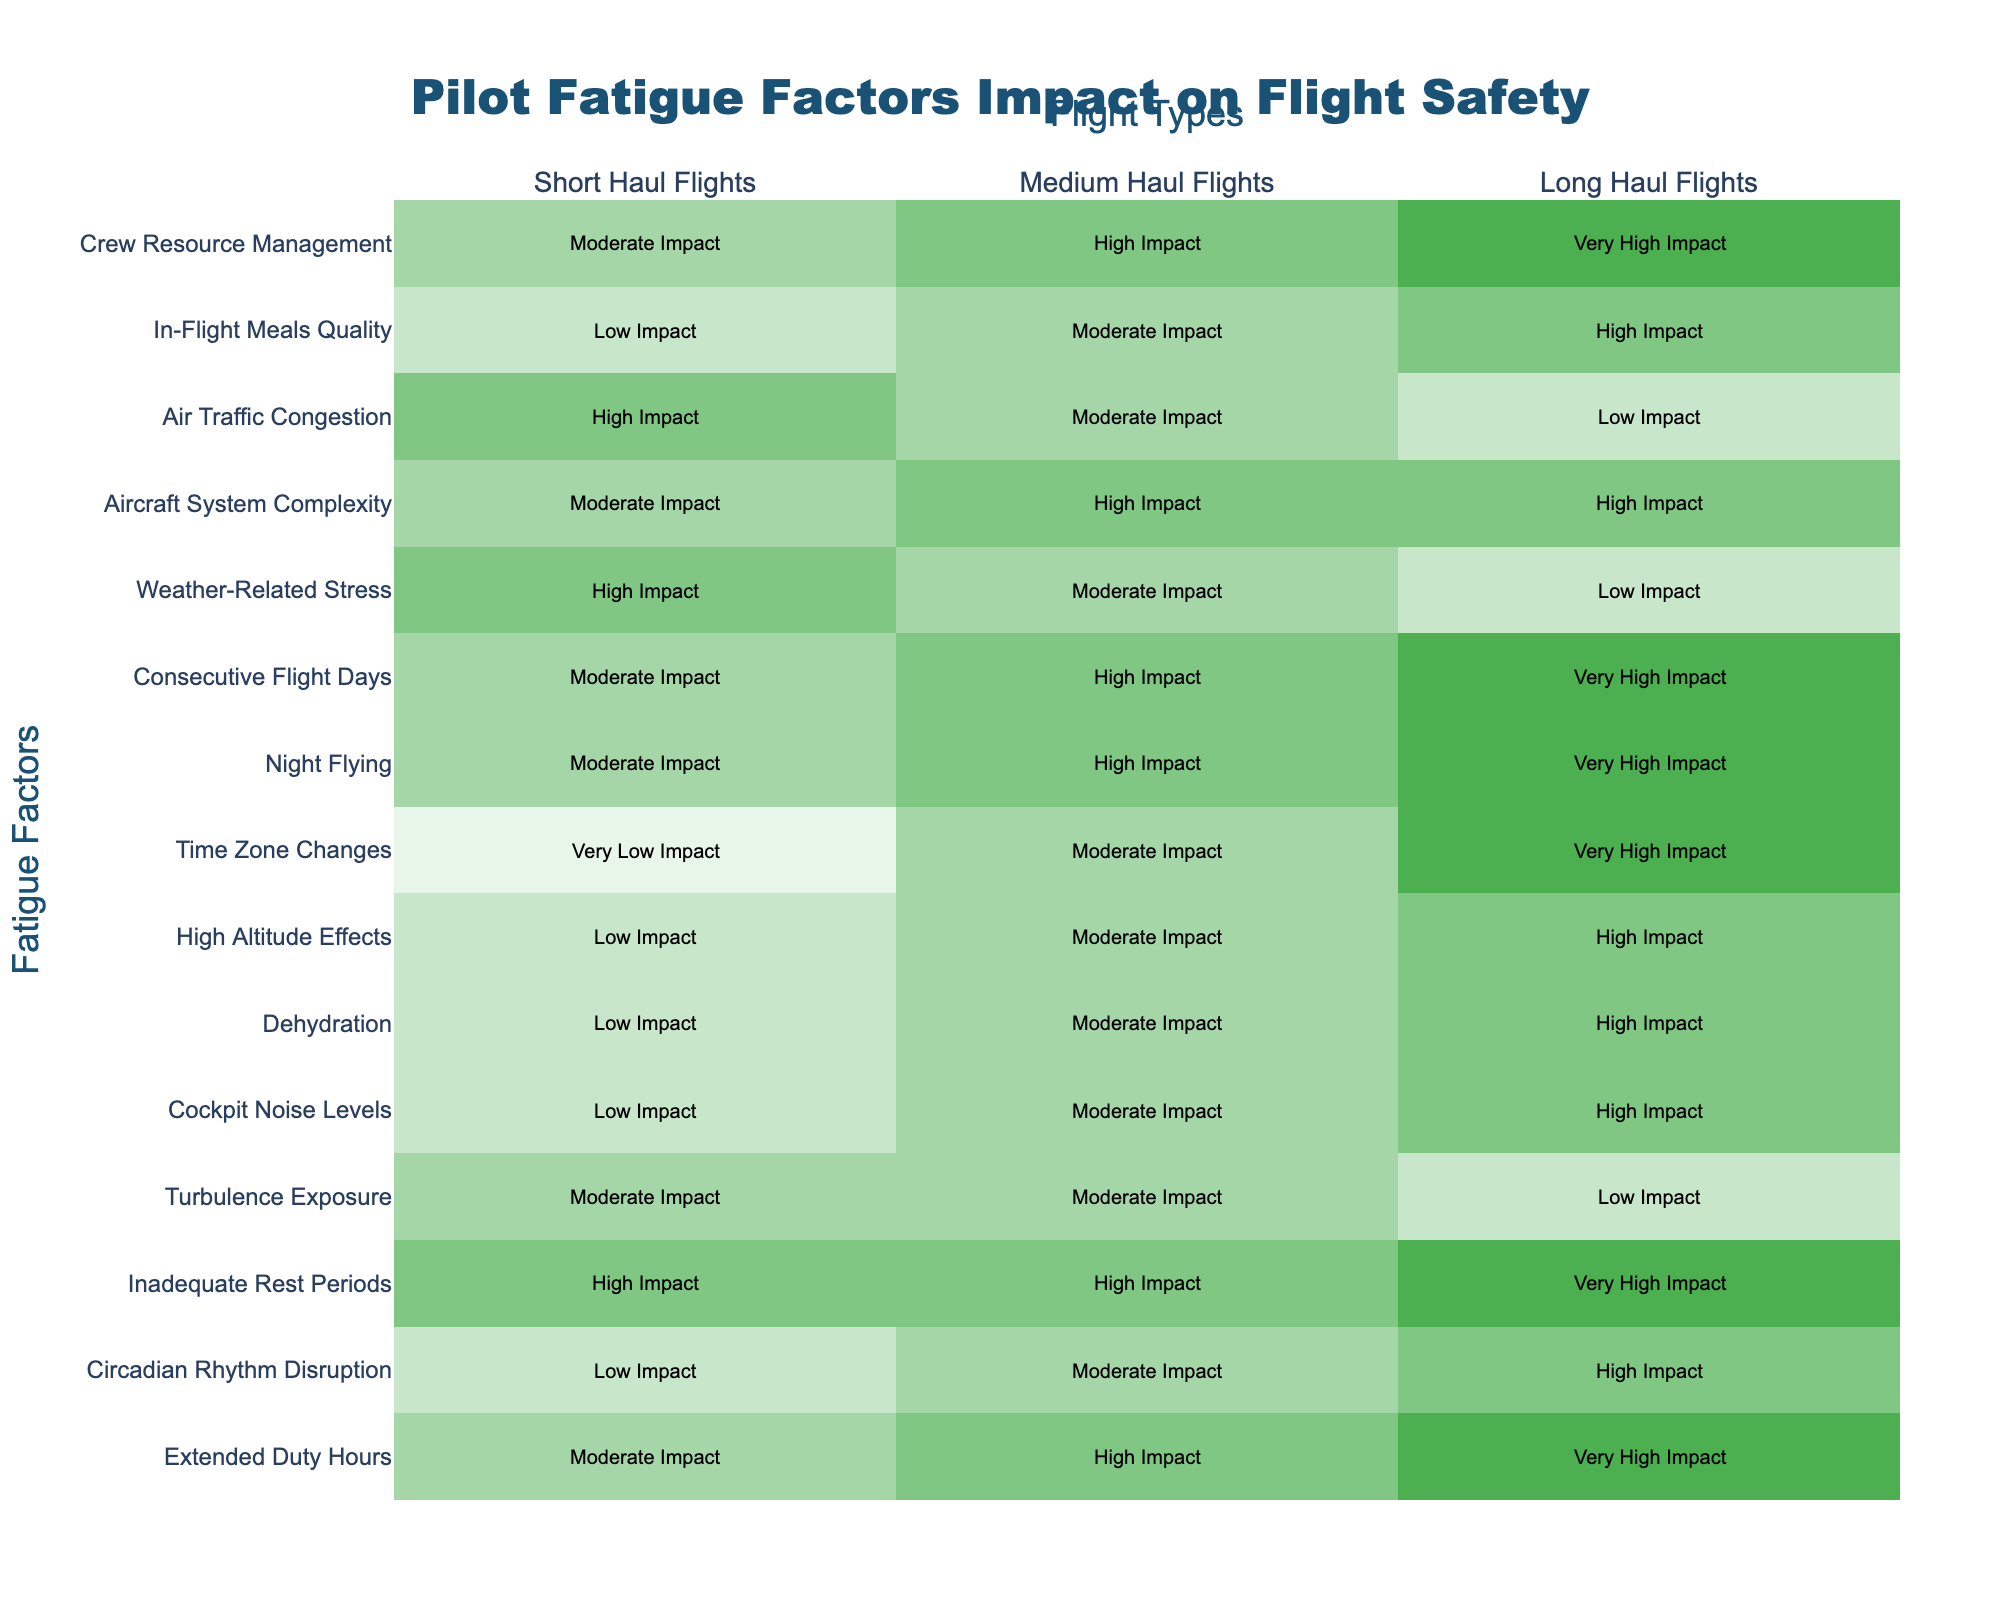What impact does "Night Flying" have on Long Haul Flights? The table indicates that "Night Flying" has a "Very High Impact" on Long Haul Flights.
Answer: Very High Impact Which fatigue factor has a "Moderate Impact" on Medium Haul Flights? Examining the table, "Cockpit Noise Levels," "Weather-Related Stress," and "Circadian Rhythm Disruption" all show a "Moderate Impact" on Medium Haul Flights.
Answer: Cockpit Noise Levels, Weather-Related Stress, Circadian Rhythm Disruption True or False: Inadequate Rest Periods have a "Very High Impact" on Short Haul Flights. The table indicates that "Inadequate Rest Periods" have a "High Impact" on Short Haul Flights, therefore the statement is false.
Answer: False Which factor is impacted the most across all flight types? Reviewing the table, "Inadequate Rest Periods" and "Time Zone Changes" both exhibit "Very High Impact" on Long Haul Flights, while "Inadequate Rest Periods" is also "High Impact" for Medium Haul Flights and "High Impact" for Short Haul Flights. Thus, it is consistently high across multiple categories.
Answer: Inadequate Rest Periods On Medium Haul Flights, which fatigue factor has a higher impact: High Altitude Effects or Cockpit Noise Levels? The table shows that "Cockpit Noise Levels" have a "Moderate Impact," whereas "High Altitude Effects" also have a "Moderate Impact." Therefore, they are equal in impact on Medium Haul Flights.
Answer: They have equal impact What is the difference in impact for "Circadian Rhythm Disruption" between Short Haul Flights and Long Haul Flights? The table shows "Circadian Rhythm Disruption" is categorized as "Low Impact" for Short Haul Flights and "High Impact" for Long Haul Flights, representing a difference of two levels in impact.
Answer: Two levels How do consecutive flight days impact Long Haul Flights compared to Short Haul Flights? In the table, "Consecutive Flight Days" show a "Very High Impact" on Long Haul Flights and a "Moderate Impact" on Short Haul Flights, indicating a significant difference in how these factors affect flight safety.
Answer: Long Haul Flights are impacted more If we average the impact levels for "Crew Resource Management," what would it be across all flight types? "Crew Resource Management" has "Moderate Impact" for Short Haul (2), "High Impact" for Medium Haul (3), and "Very High Impact" for Long Haul (4). The average is (2 + 3 + 4)/3 = 3, which corresponds to "High Impact."
Answer: High Impact Which fatigue factor is ranked highest for Short Haul Flights? The table reveals that the highest impact factor for Short Haul Flights is "Inadequate Rest Periods, " which shows a "High Impact."
Answer: Inadequate Rest Periods 